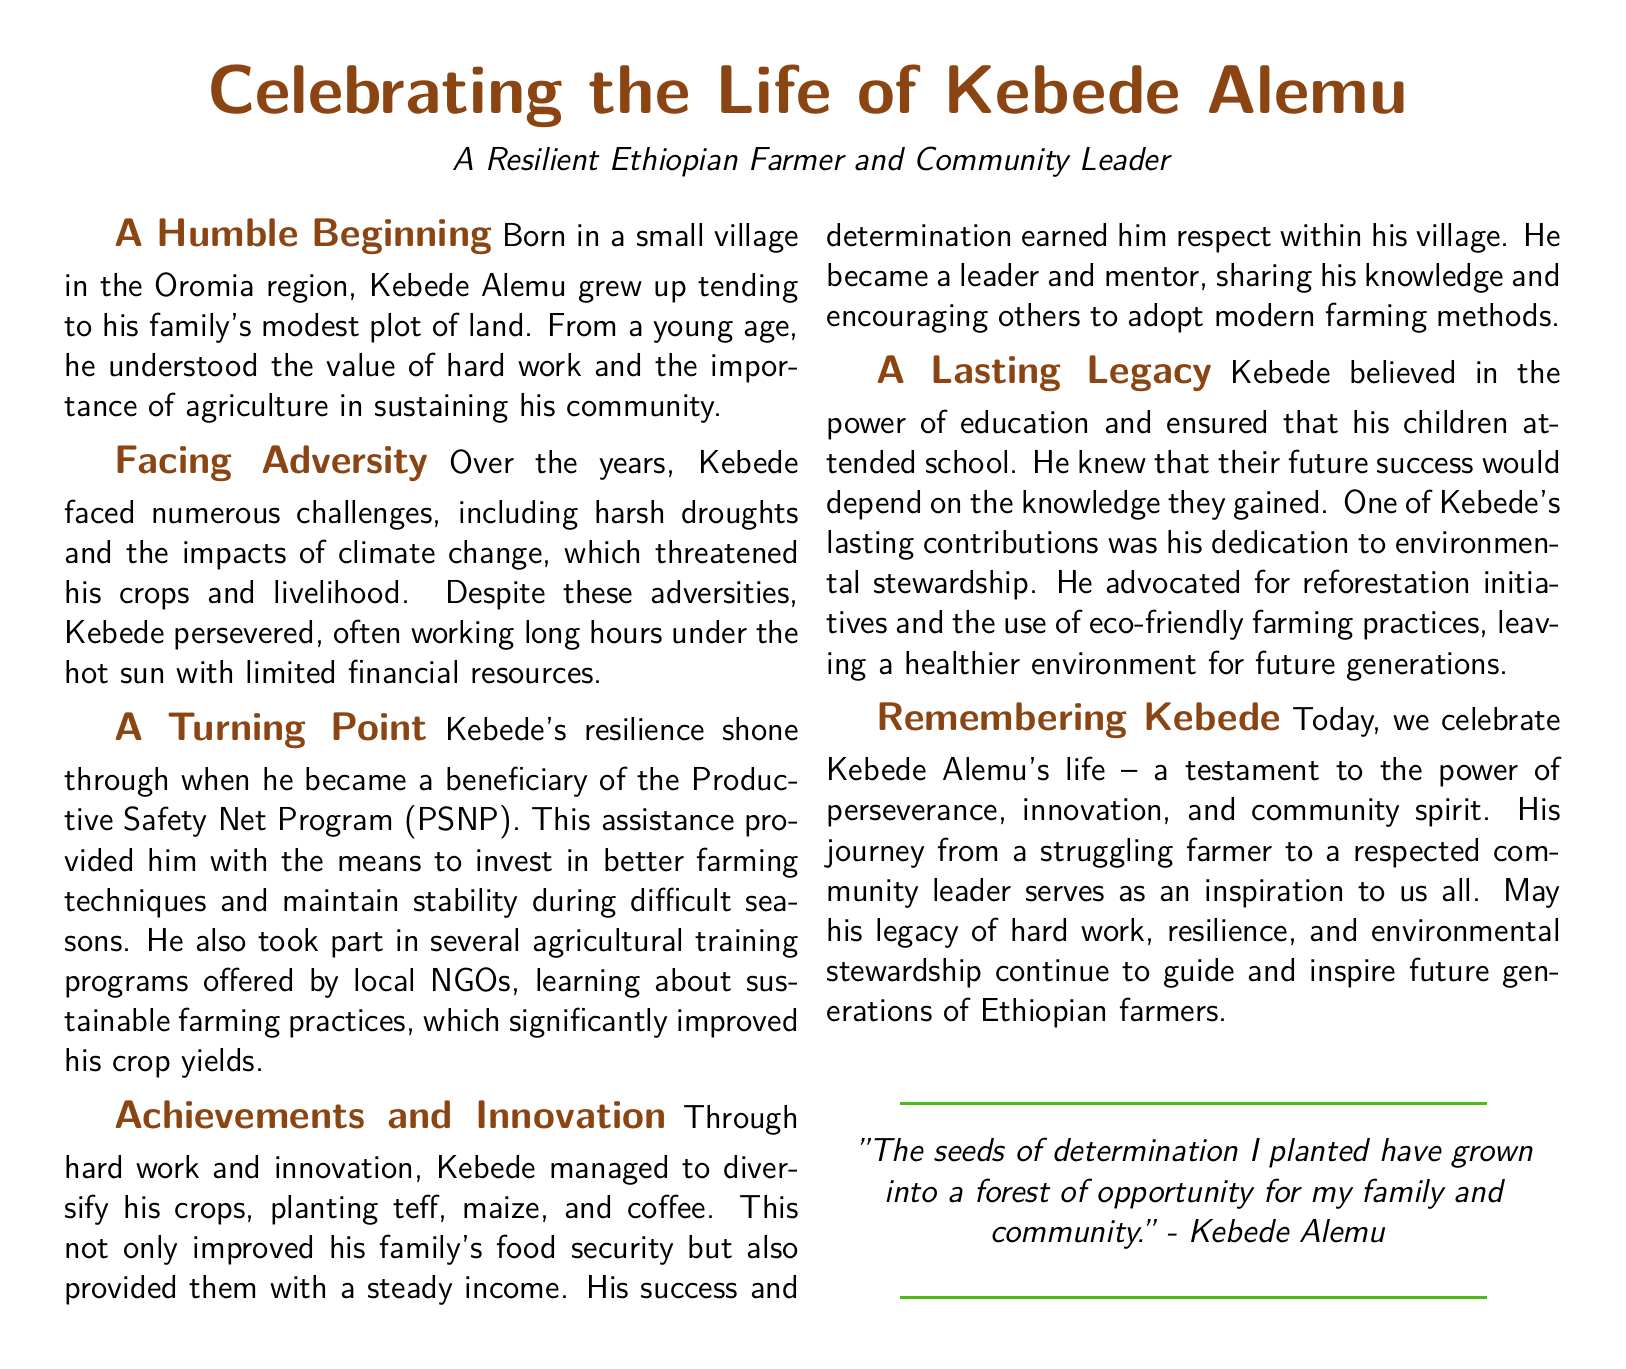What is the name of the farmer celebrated in the eulogy? The eulogy celebrates the life of Kebede Alemu.
Answer: Kebede Alemu In which region was Kebede born? Kebede was born in the Oromia region.
Answer: Oromia What program assisted Kebede in investing in better farming techniques? The Productive Safety Net Program (PSNP) provided assistance.
Answer: Productive Safety Net Program (PSNP) What type of crops did Kebede plant to diversify his farming? Kebede planted teff, maize, and coffee to diversify his crops.
Answer: teff, maize, and coffee What was one of Kebede's lasting contributions? Kebede's dedication to environmental stewardship was a lasting contribution.
Answer: Environmental stewardship How did Kebede's perseverance affect his community? His perseverance earned him respect within his village and he became a leader.
Answer: He became a leader What did Kebede ensure for his children's future? Kebede ensured that his children attended school for a better future.
Answer: Attended school What phrase did Kebede use to express his determination? Kebede said, "The seeds of determination I planted have grown into a forest of opportunity."
Answer: "The seeds of determination I planted have grown into a forest of opportunity." What type of farming practices did Kebede advocate? Kebede advocated for eco-friendly farming practices.
Answer: Eco-friendly farming practices 